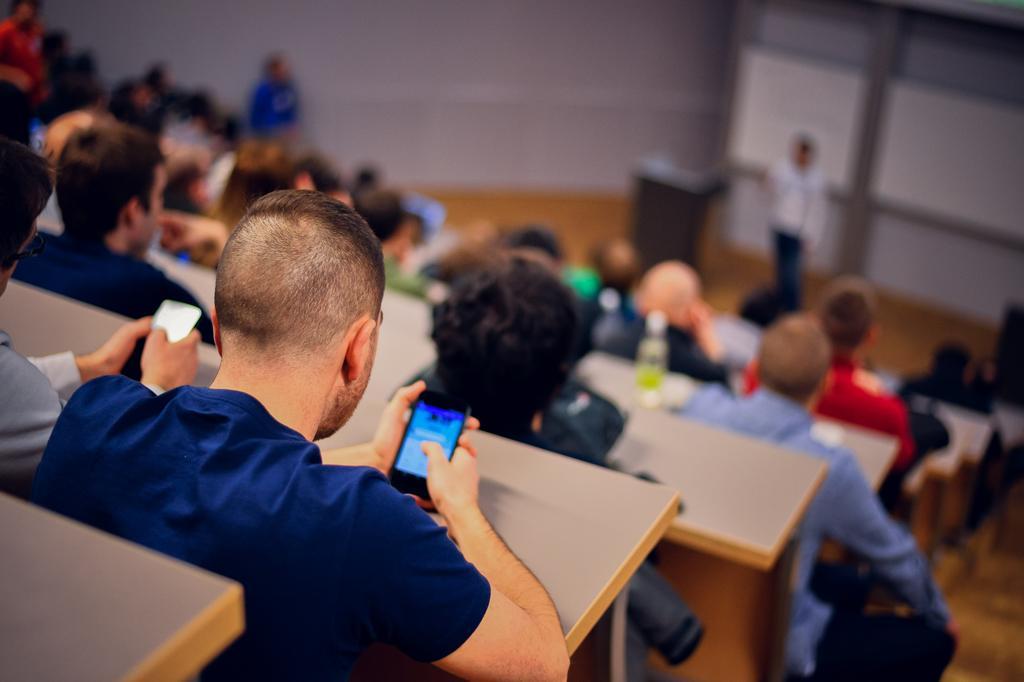Please provide a concise description of this image. In this image we can see people sitting on benches. To the right side of the image there is a person there is a podium. 